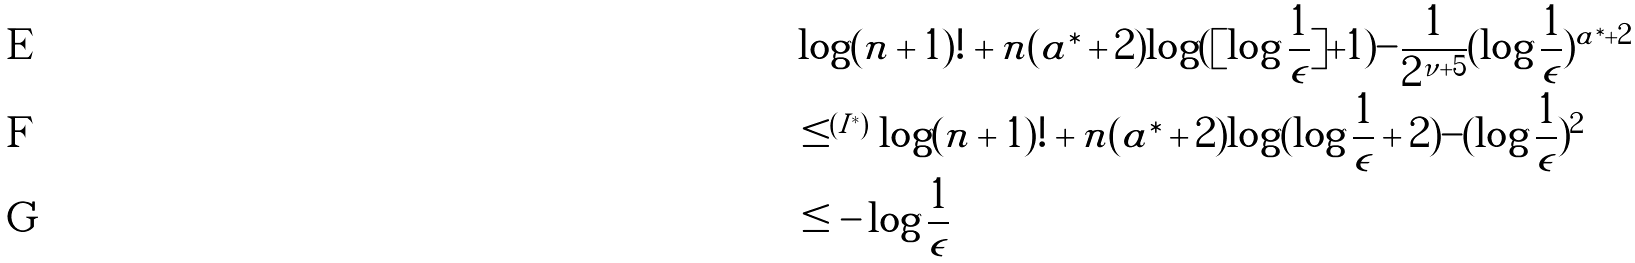Convert formula to latex. <formula><loc_0><loc_0><loc_500><loc_500>& \log ( n + 1 ) ! + n ( a ^ { \ast } + 2 ) \log ( [ \log \frac { 1 } { \epsilon } ] + 1 ) - \frac { 1 } { 2 ^ { \nu + 5 } } ( \log \frac { 1 } { \epsilon } ) ^ { a ^ { \ast } + 2 } \\ & \leq ^ { ( I ^ { * } ) } \log ( n + 1 ) ! + n ( a ^ { \ast } + 2 ) \log ( \log \frac { 1 } { \epsilon } + 2 ) - ( \log \frac { 1 } { \epsilon } ) ^ { 2 } \\ & \leq - \log \frac { 1 } { \epsilon }</formula> 